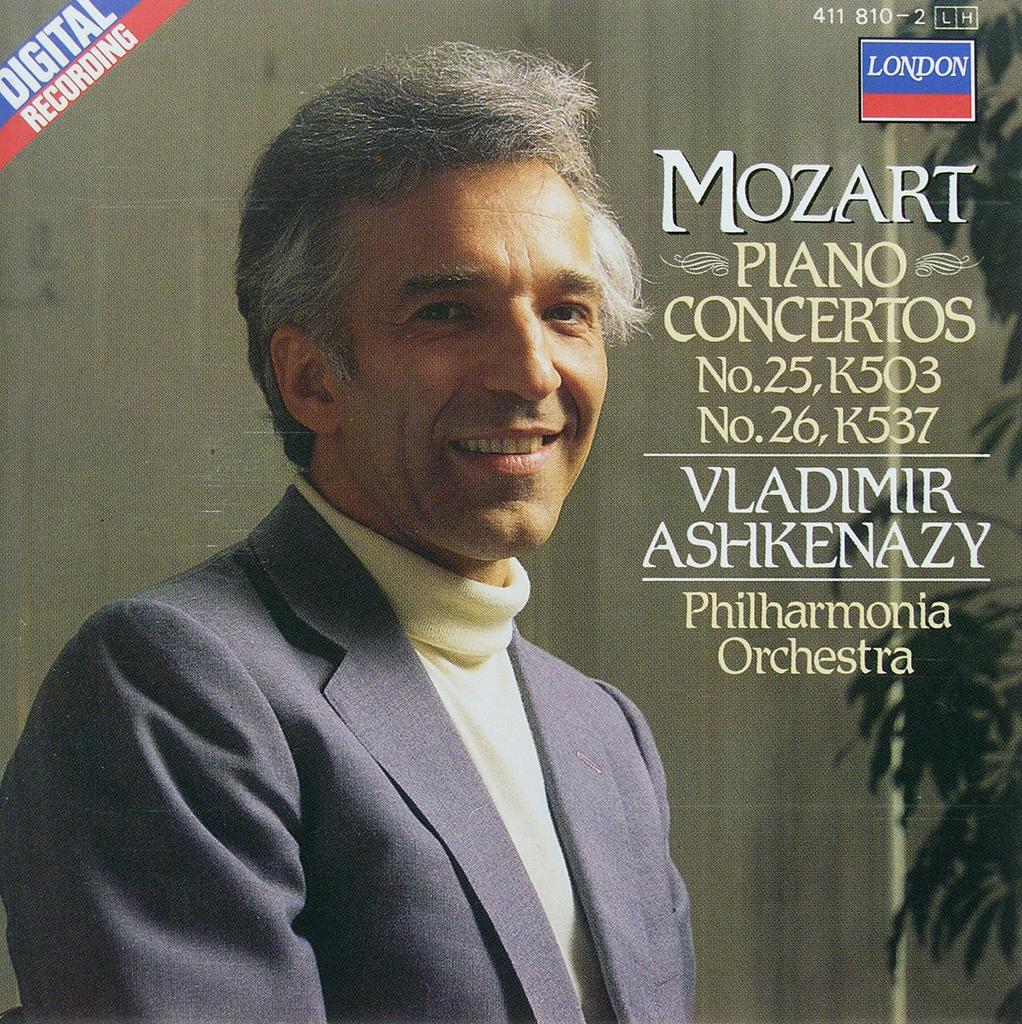<image>
Share a concise interpretation of the image provided. a cover of a sd that says 'mozart piano concertos' on it 